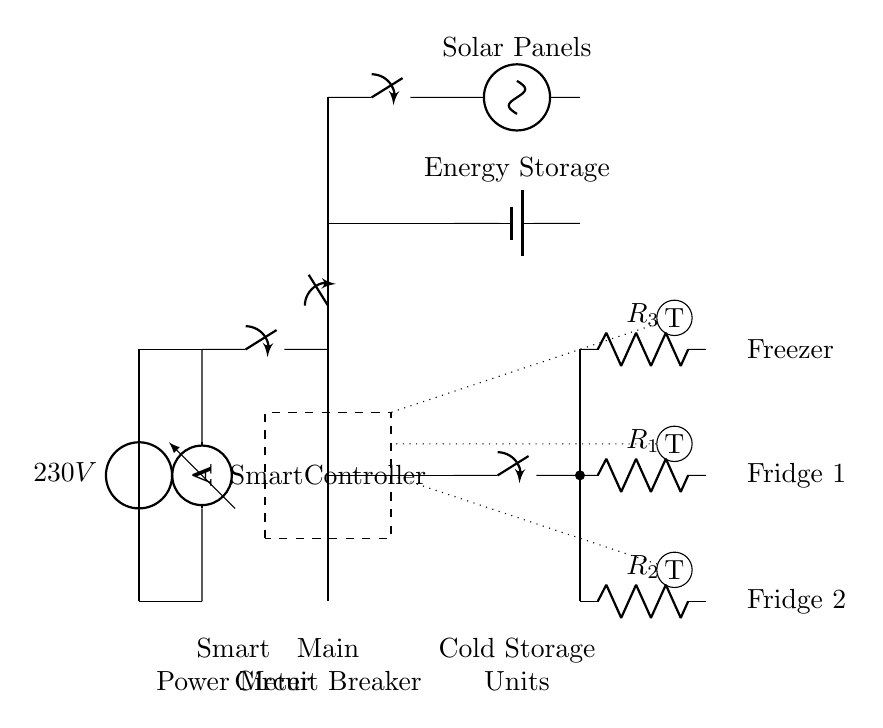What is the voltage of this circuit? The circuit is supplied by a voltage source labeled as 230V. This indicates the potential difference provided to the components in the circuit.
Answer: 230V What are the three types of cold storage units depicted? The circuit shows three types of refrigeration units identified as Fridge 1, Fridge 2, and a Freezer. These units are labeled next to their corresponding resistors in the circuit diagram.
Answer: Fridge 1, Fridge 2, Freezer What is the purpose of the smart controller in this circuit? The smart controller, located within the dashed rectangle, manages the operation of the cold storage units by coordinating energy supply and optimizing efficiency based on sensor input.
Answer: Energy management How many switches are shown in the circuit? There are four closing switches in total: one for the main circuit breaker, two for the refrigeration units, and one for the solar panel input.
Answer: Four Which component connects the energy storage system to the main circuit? The energy storage system is connected to the main circuit via a closing switch directly above the energy storage labeled as battery1. This bridge facilitates the flow of energy during operation.
Answer: Closing switch How do the sensors contribute to the functionality of the cold storage units? The sensors (temperature sensors denoted as T) provide real-time temperature data to the smart controller, ensuring that the refrigeration units maintain optimal operating conditions by adjusting power usage as necessary.
Answer: Real-time temperature monitoring 